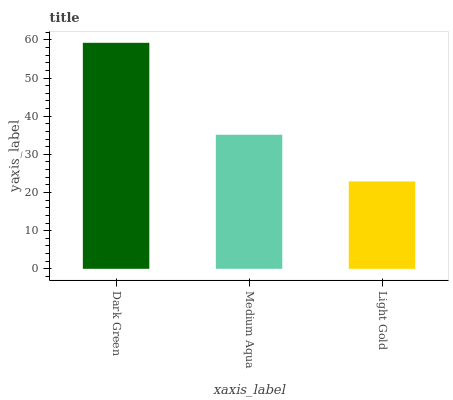Is Medium Aqua the minimum?
Answer yes or no. No. Is Medium Aqua the maximum?
Answer yes or no. No. Is Dark Green greater than Medium Aqua?
Answer yes or no. Yes. Is Medium Aqua less than Dark Green?
Answer yes or no. Yes. Is Medium Aqua greater than Dark Green?
Answer yes or no. No. Is Dark Green less than Medium Aqua?
Answer yes or no. No. Is Medium Aqua the high median?
Answer yes or no. Yes. Is Medium Aqua the low median?
Answer yes or no. Yes. Is Light Gold the high median?
Answer yes or no. No. Is Dark Green the low median?
Answer yes or no. No. 